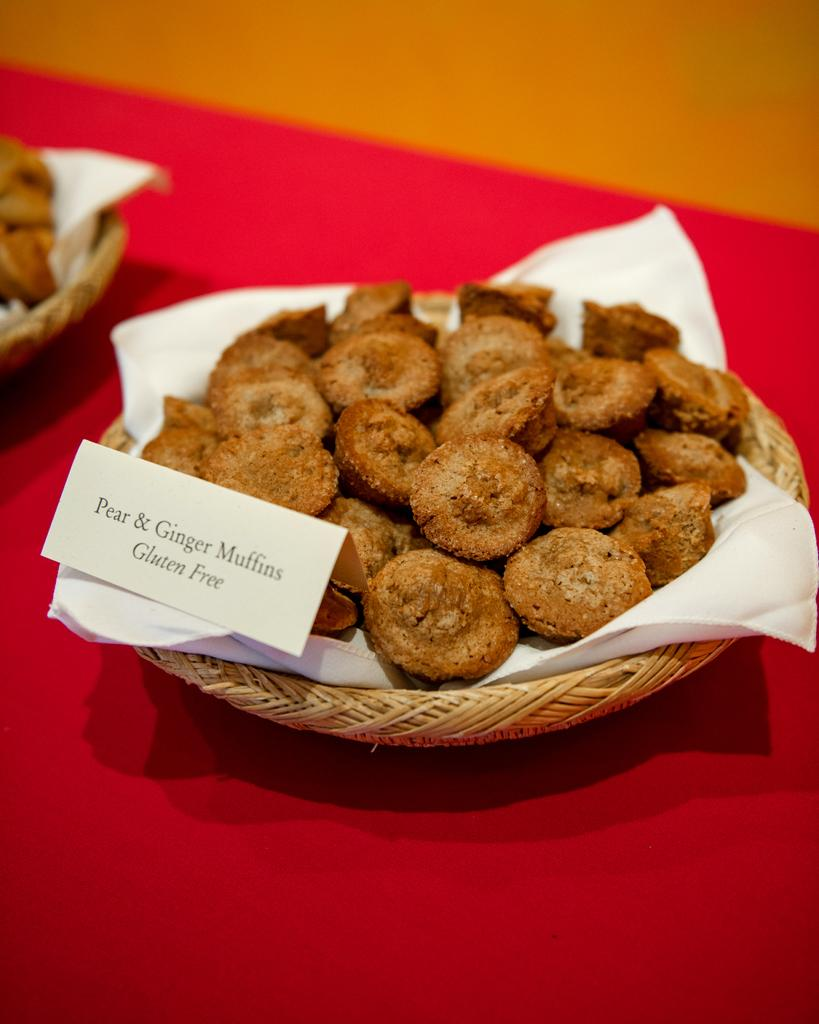What is the main subject of the image? The main subject of the image is food. Where is the food located in the image? The food is on a brown color wall. What is the color of the food? The food has a brown color. What other objects can be seen in the image besides the food? There are balls in the image. What is the color of the surface on which the balls are placed? The balls are on a red color surface. How does the food compare to a plate in the image? There is no plate present in the image for comparison. What type of sponge can be seen absorbing water in the image? There is no sponge present in the image. 